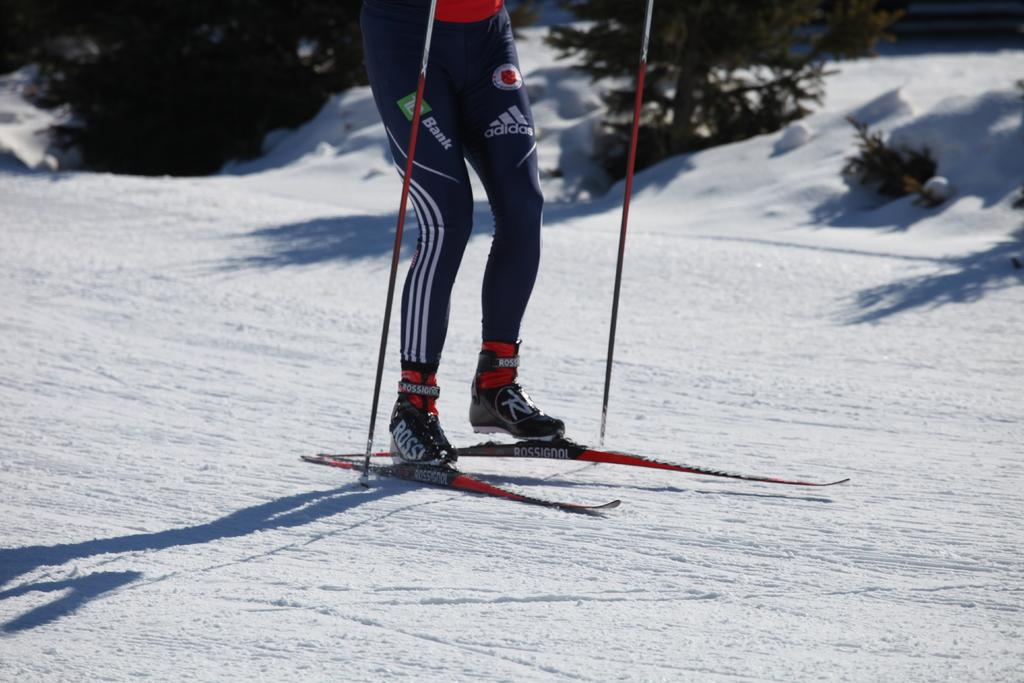What is the main subject of the image? There is a person in the image. What is the person wearing on their feet? The person is wearing shoes. What is the person doing in the image? The person is standing on skis. What objects are in the person's hands? There are sticks in the image. What is the environment like in the image? There is snow in the image, and plants are visible in the background. What type of fruit is being used to cause trouble in the image? There is no fruit present in the image, and no trouble is depicted. 